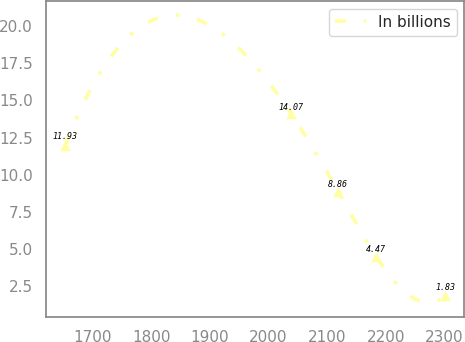Convert chart to OTSL. <chart><loc_0><loc_0><loc_500><loc_500><line_chart><ecel><fcel>In billions<nl><fcel>1652.11<fcel>11.93<nl><fcel>2038.88<fcel>14.07<nl><fcel>2118.76<fcel>8.86<nl><fcel>2183.71<fcel>4.47<nl><fcel>2301.56<fcel>1.83<nl></chart> 